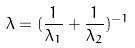Convert formula to latex. <formula><loc_0><loc_0><loc_500><loc_500>\lambda = ( \frac { 1 } { \lambda _ { 1 } } + \frac { 1 } { \lambda _ { 2 } } ) ^ { - 1 }</formula> 